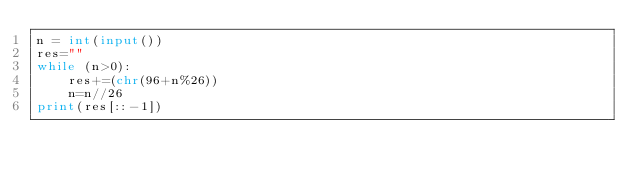<code> <loc_0><loc_0><loc_500><loc_500><_Python_>n = int(input())
res=""
while (n>0):
    res+=(chr(96+n%26))
    n=n//26
print(res[::-1])</code> 